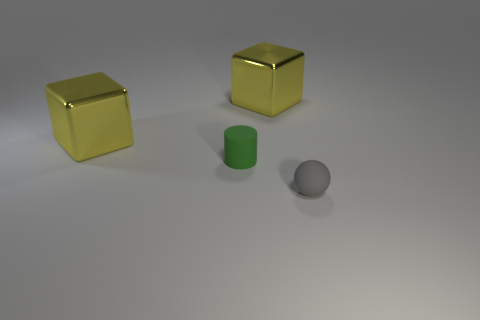Add 1 large gray shiny objects. How many objects exist? 5 Subtract all cylinders. How many objects are left? 3 Subtract 0 blue blocks. How many objects are left? 4 Subtract all small green metallic cylinders. Subtract all tiny gray things. How many objects are left? 3 Add 1 tiny gray rubber objects. How many tiny gray rubber objects are left? 2 Add 3 metallic cubes. How many metallic cubes exist? 5 